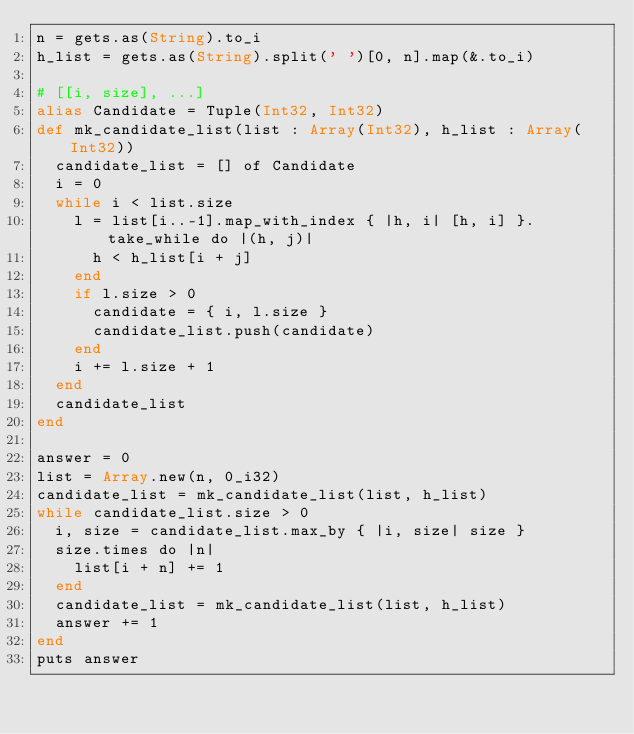<code> <loc_0><loc_0><loc_500><loc_500><_Crystal_>n = gets.as(String).to_i
h_list = gets.as(String).split(' ')[0, n].map(&.to_i)

# [[i, size], ...]
alias Candidate = Tuple(Int32, Int32)
def mk_candidate_list(list : Array(Int32), h_list : Array(Int32))
  candidate_list = [] of Candidate
  i = 0
  while i < list.size
    l = list[i..-1].map_with_index { |h, i| [h, i] }.take_while do |(h, j)|
      h < h_list[i + j]
    end
    if l.size > 0
      candidate = { i, l.size }
      candidate_list.push(candidate)
    end
    i += l.size + 1
  end
  candidate_list
end

answer = 0
list = Array.new(n, 0_i32)
candidate_list = mk_candidate_list(list, h_list)
while candidate_list.size > 0
  i, size = candidate_list.max_by { |i, size| size }
  size.times do |n|
    list[i + n] += 1
  end
  candidate_list = mk_candidate_list(list, h_list)
  answer += 1
end
puts answer</code> 